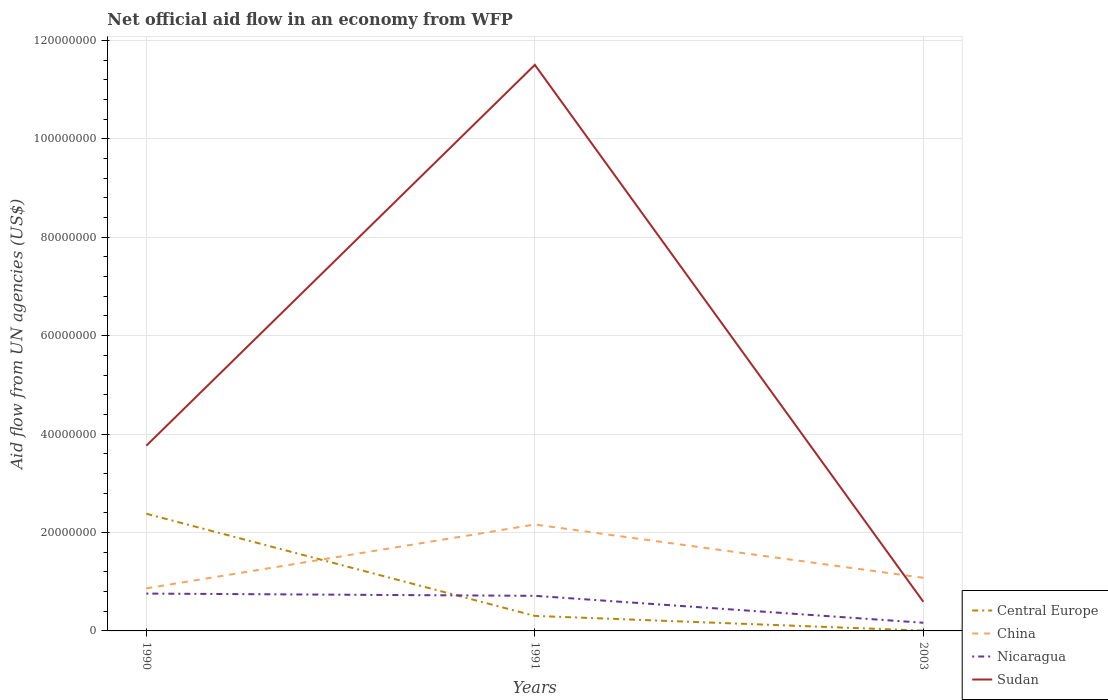Across all years, what is the maximum net official aid flow in Nicaragua?
Provide a succinct answer. 1.66e+06. What is the total net official aid flow in Nicaragua in the graph?
Your answer should be very brief. 4.60e+05. What is the difference between the highest and the second highest net official aid flow in China?
Your answer should be compact. 1.30e+07. What is the difference between the highest and the lowest net official aid flow in Central Europe?
Provide a succinct answer. 1. Is the net official aid flow in China strictly greater than the net official aid flow in Sudan over the years?
Provide a succinct answer. No. How many lines are there?
Provide a short and direct response. 4. How many years are there in the graph?
Your answer should be compact. 3. Does the graph contain any zero values?
Your answer should be compact. No. How are the legend labels stacked?
Offer a very short reply. Vertical. What is the title of the graph?
Your answer should be very brief. Net official aid flow in an economy from WFP. What is the label or title of the Y-axis?
Give a very brief answer. Aid flow from UN agencies (US$). What is the Aid flow from UN agencies (US$) in Central Europe in 1990?
Give a very brief answer. 2.38e+07. What is the Aid flow from UN agencies (US$) in China in 1990?
Give a very brief answer. 8.65e+06. What is the Aid flow from UN agencies (US$) in Nicaragua in 1990?
Your response must be concise. 7.59e+06. What is the Aid flow from UN agencies (US$) in Sudan in 1990?
Your response must be concise. 3.76e+07. What is the Aid flow from UN agencies (US$) of Central Europe in 1991?
Offer a terse response. 3.05e+06. What is the Aid flow from UN agencies (US$) in China in 1991?
Provide a succinct answer. 2.16e+07. What is the Aid flow from UN agencies (US$) of Nicaragua in 1991?
Keep it short and to the point. 7.13e+06. What is the Aid flow from UN agencies (US$) of Sudan in 1991?
Offer a very short reply. 1.15e+08. What is the Aid flow from UN agencies (US$) of Central Europe in 2003?
Your answer should be compact. 6.00e+04. What is the Aid flow from UN agencies (US$) of China in 2003?
Your answer should be compact. 1.08e+07. What is the Aid flow from UN agencies (US$) of Nicaragua in 2003?
Your answer should be compact. 1.66e+06. What is the Aid flow from UN agencies (US$) of Sudan in 2003?
Your answer should be compact. 5.92e+06. Across all years, what is the maximum Aid flow from UN agencies (US$) in Central Europe?
Make the answer very short. 2.38e+07. Across all years, what is the maximum Aid flow from UN agencies (US$) of China?
Provide a short and direct response. 2.16e+07. Across all years, what is the maximum Aid flow from UN agencies (US$) of Nicaragua?
Your answer should be very brief. 7.59e+06. Across all years, what is the maximum Aid flow from UN agencies (US$) of Sudan?
Keep it short and to the point. 1.15e+08. Across all years, what is the minimum Aid flow from UN agencies (US$) in China?
Ensure brevity in your answer.  8.65e+06. Across all years, what is the minimum Aid flow from UN agencies (US$) in Nicaragua?
Offer a very short reply. 1.66e+06. Across all years, what is the minimum Aid flow from UN agencies (US$) of Sudan?
Your answer should be very brief. 5.92e+06. What is the total Aid flow from UN agencies (US$) of Central Europe in the graph?
Give a very brief answer. 2.69e+07. What is the total Aid flow from UN agencies (US$) of China in the graph?
Your response must be concise. 4.11e+07. What is the total Aid flow from UN agencies (US$) in Nicaragua in the graph?
Your answer should be compact. 1.64e+07. What is the total Aid flow from UN agencies (US$) of Sudan in the graph?
Provide a succinct answer. 1.59e+08. What is the difference between the Aid flow from UN agencies (US$) of Central Europe in 1990 and that in 1991?
Offer a terse response. 2.08e+07. What is the difference between the Aid flow from UN agencies (US$) of China in 1990 and that in 1991?
Provide a succinct answer. -1.30e+07. What is the difference between the Aid flow from UN agencies (US$) in Sudan in 1990 and that in 1991?
Keep it short and to the point. -7.74e+07. What is the difference between the Aid flow from UN agencies (US$) in Central Europe in 1990 and that in 2003?
Your answer should be compact. 2.38e+07. What is the difference between the Aid flow from UN agencies (US$) in China in 1990 and that in 2003?
Offer a terse response. -2.14e+06. What is the difference between the Aid flow from UN agencies (US$) in Nicaragua in 1990 and that in 2003?
Provide a short and direct response. 5.93e+06. What is the difference between the Aid flow from UN agencies (US$) in Sudan in 1990 and that in 2003?
Your answer should be very brief. 3.17e+07. What is the difference between the Aid flow from UN agencies (US$) in Central Europe in 1991 and that in 2003?
Offer a terse response. 2.99e+06. What is the difference between the Aid flow from UN agencies (US$) of China in 1991 and that in 2003?
Keep it short and to the point. 1.08e+07. What is the difference between the Aid flow from UN agencies (US$) of Nicaragua in 1991 and that in 2003?
Ensure brevity in your answer.  5.47e+06. What is the difference between the Aid flow from UN agencies (US$) of Sudan in 1991 and that in 2003?
Provide a short and direct response. 1.09e+08. What is the difference between the Aid flow from UN agencies (US$) of Central Europe in 1990 and the Aid flow from UN agencies (US$) of China in 1991?
Give a very brief answer. 2.19e+06. What is the difference between the Aid flow from UN agencies (US$) of Central Europe in 1990 and the Aid flow from UN agencies (US$) of Nicaragua in 1991?
Offer a very short reply. 1.67e+07. What is the difference between the Aid flow from UN agencies (US$) in Central Europe in 1990 and the Aid flow from UN agencies (US$) in Sudan in 1991?
Your response must be concise. -9.12e+07. What is the difference between the Aid flow from UN agencies (US$) in China in 1990 and the Aid flow from UN agencies (US$) in Nicaragua in 1991?
Provide a succinct answer. 1.52e+06. What is the difference between the Aid flow from UN agencies (US$) in China in 1990 and the Aid flow from UN agencies (US$) in Sudan in 1991?
Provide a short and direct response. -1.06e+08. What is the difference between the Aid flow from UN agencies (US$) in Nicaragua in 1990 and the Aid flow from UN agencies (US$) in Sudan in 1991?
Provide a short and direct response. -1.07e+08. What is the difference between the Aid flow from UN agencies (US$) of Central Europe in 1990 and the Aid flow from UN agencies (US$) of China in 2003?
Offer a terse response. 1.30e+07. What is the difference between the Aid flow from UN agencies (US$) of Central Europe in 1990 and the Aid flow from UN agencies (US$) of Nicaragua in 2003?
Your response must be concise. 2.22e+07. What is the difference between the Aid flow from UN agencies (US$) of Central Europe in 1990 and the Aid flow from UN agencies (US$) of Sudan in 2003?
Make the answer very short. 1.79e+07. What is the difference between the Aid flow from UN agencies (US$) of China in 1990 and the Aid flow from UN agencies (US$) of Nicaragua in 2003?
Provide a succinct answer. 6.99e+06. What is the difference between the Aid flow from UN agencies (US$) of China in 1990 and the Aid flow from UN agencies (US$) of Sudan in 2003?
Your response must be concise. 2.73e+06. What is the difference between the Aid flow from UN agencies (US$) of Nicaragua in 1990 and the Aid flow from UN agencies (US$) of Sudan in 2003?
Provide a short and direct response. 1.67e+06. What is the difference between the Aid flow from UN agencies (US$) in Central Europe in 1991 and the Aid flow from UN agencies (US$) in China in 2003?
Give a very brief answer. -7.74e+06. What is the difference between the Aid flow from UN agencies (US$) in Central Europe in 1991 and the Aid flow from UN agencies (US$) in Nicaragua in 2003?
Keep it short and to the point. 1.39e+06. What is the difference between the Aid flow from UN agencies (US$) in Central Europe in 1991 and the Aid flow from UN agencies (US$) in Sudan in 2003?
Keep it short and to the point. -2.87e+06. What is the difference between the Aid flow from UN agencies (US$) in China in 1991 and the Aid flow from UN agencies (US$) in Nicaragua in 2003?
Your response must be concise. 2.00e+07. What is the difference between the Aid flow from UN agencies (US$) in China in 1991 and the Aid flow from UN agencies (US$) in Sudan in 2003?
Provide a succinct answer. 1.57e+07. What is the difference between the Aid flow from UN agencies (US$) in Nicaragua in 1991 and the Aid flow from UN agencies (US$) in Sudan in 2003?
Keep it short and to the point. 1.21e+06. What is the average Aid flow from UN agencies (US$) in Central Europe per year?
Offer a very short reply. 8.97e+06. What is the average Aid flow from UN agencies (US$) of China per year?
Your answer should be compact. 1.37e+07. What is the average Aid flow from UN agencies (US$) of Nicaragua per year?
Ensure brevity in your answer.  5.46e+06. What is the average Aid flow from UN agencies (US$) of Sudan per year?
Give a very brief answer. 5.29e+07. In the year 1990, what is the difference between the Aid flow from UN agencies (US$) in Central Europe and Aid flow from UN agencies (US$) in China?
Offer a very short reply. 1.52e+07. In the year 1990, what is the difference between the Aid flow from UN agencies (US$) of Central Europe and Aid flow from UN agencies (US$) of Nicaragua?
Give a very brief answer. 1.62e+07. In the year 1990, what is the difference between the Aid flow from UN agencies (US$) of Central Europe and Aid flow from UN agencies (US$) of Sudan?
Keep it short and to the point. -1.38e+07. In the year 1990, what is the difference between the Aid flow from UN agencies (US$) in China and Aid flow from UN agencies (US$) in Nicaragua?
Offer a terse response. 1.06e+06. In the year 1990, what is the difference between the Aid flow from UN agencies (US$) of China and Aid flow from UN agencies (US$) of Sudan?
Your answer should be very brief. -2.90e+07. In the year 1990, what is the difference between the Aid flow from UN agencies (US$) of Nicaragua and Aid flow from UN agencies (US$) of Sudan?
Your response must be concise. -3.00e+07. In the year 1991, what is the difference between the Aid flow from UN agencies (US$) of Central Europe and Aid flow from UN agencies (US$) of China?
Make the answer very short. -1.86e+07. In the year 1991, what is the difference between the Aid flow from UN agencies (US$) in Central Europe and Aid flow from UN agencies (US$) in Nicaragua?
Provide a short and direct response. -4.08e+06. In the year 1991, what is the difference between the Aid flow from UN agencies (US$) of Central Europe and Aid flow from UN agencies (US$) of Sudan?
Ensure brevity in your answer.  -1.12e+08. In the year 1991, what is the difference between the Aid flow from UN agencies (US$) of China and Aid flow from UN agencies (US$) of Nicaragua?
Offer a terse response. 1.45e+07. In the year 1991, what is the difference between the Aid flow from UN agencies (US$) of China and Aid flow from UN agencies (US$) of Sudan?
Ensure brevity in your answer.  -9.34e+07. In the year 1991, what is the difference between the Aid flow from UN agencies (US$) of Nicaragua and Aid flow from UN agencies (US$) of Sudan?
Provide a succinct answer. -1.08e+08. In the year 2003, what is the difference between the Aid flow from UN agencies (US$) in Central Europe and Aid flow from UN agencies (US$) in China?
Make the answer very short. -1.07e+07. In the year 2003, what is the difference between the Aid flow from UN agencies (US$) in Central Europe and Aid flow from UN agencies (US$) in Nicaragua?
Your answer should be very brief. -1.60e+06. In the year 2003, what is the difference between the Aid flow from UN agencies (US$) in Central Europe and Aid flow from UN agencies (US$) in Sudan?
Make the answer very short. -5.86e+06. In the year 2003, what is the difference between the Aid flow from UN agencies (US$) of China and Aid flow from UN agencies (US$) of Nicaragua?
Offer a very short reply. 9.13e+06. In the year 2003, what is the difference between the Aid flow from UN agencies (US$) in China and Aid flow from UN agencies (US$) in Sudan?
Your response must be concise. 4.87e+06. In the year 2003, what is the difference between the Aid flow from UN agencies (US$) of Nicaragua and Aid flow from UN agencies (US$) of Sudan?
Provide a short and direct response. -4.26e+06. What is the ratio of the Aid flow from UN agencies (US$) in Central Europe in 1990 to that in 1991?
Ensure brevity in your answer.  7.81. What is the ratio of the Aid flow from UN agencies (US$) in China in 1990 to that in 1991?
Your answer should be compact. 0.4. What is the ratio of the Aid flow from UN agencies (US$) of Nicaragua in 1990 to that in 1991?
Provide a succinct answer. 1.06. What is the ratio of the Aid flow from UN agencies (US$) in Sudan in 1990 to that in 1991?
Your answer should be compact. 0.33. What is the ratio of the Aid flow from UN agencies (US$) of Central Europe in 1990 to that in 2003?
Your response must be concise. 396.83. What is the ratio of the Aid flow from UN agencies (US$) of China in 1990 to that in 2003?
Give a very brief answer. 0.8. What is the ratio of the Aid flow from UN agencies (US$) of Nicaragua in 1990 to that in 2003?
Give a very brief answer. 4.57. What is the ratio of the Aid flow from UN agencies (US$) of Sudan in 1990 to that in 2003?
Give a very brief answer. 6.36. What is the ratio of the Aid flow from UN agencies (US$) in Central Europe in 1991 to that in 2003?
Provide a succinct answer. 50.83. What is the ratio of the Aid flow from UN agencies (US$) in China in 1991 to that in 2003?
Make the answer very short. 2. What is the ratio of the Aid flow from UN agencies (US$) of Nicaragua in 1991 to that in 2003?
Give a very brief answer. 4.3. What is the ratio of the Aid flow from UN agencies (US$) of Sudan in 1991 to that in 2003?
Keep it short and to the point. 19.43. What is the difference between the highest and the second highest Aid flow from UN agencies (US$) of Central Europe?
Offer a very short reply. 2.08e+07. What is the difference between the highest and the second highest Aid flow from UN agencies (US$) in China?
Ensure brevity in your answer.  1.08e+07. What is the difference between the highest and the second highest Aid flow from UN agencies (US$) of Nicaragua?
Ensure brevity in your answer.  4.60e+05. What is the difference between the highest and the second highest Aid flow from UN agencies (US$) of Sudan?
Your answer should be very brief. 7.74e+07. What is the difference between the highest and the lowest Aid flow from UN agencies (US$) in Central Europe?
Provide a short and direct response. 2.38e+07. What is the difference between the highest and the lowest Aid flow from UN agencies (US$) of China?
Provide a succinct answer. 1.30e+07. What is the difference between the highest and the lowest Aid flow from UN agencies (US$) in Nicaragua?
Give a very brief answer. 5.93e+06. What is the difference between the highest and the lowest Aid flow from UN agencies (US$) in Sudan?
Give a very brief answer. 1.09e+08. 